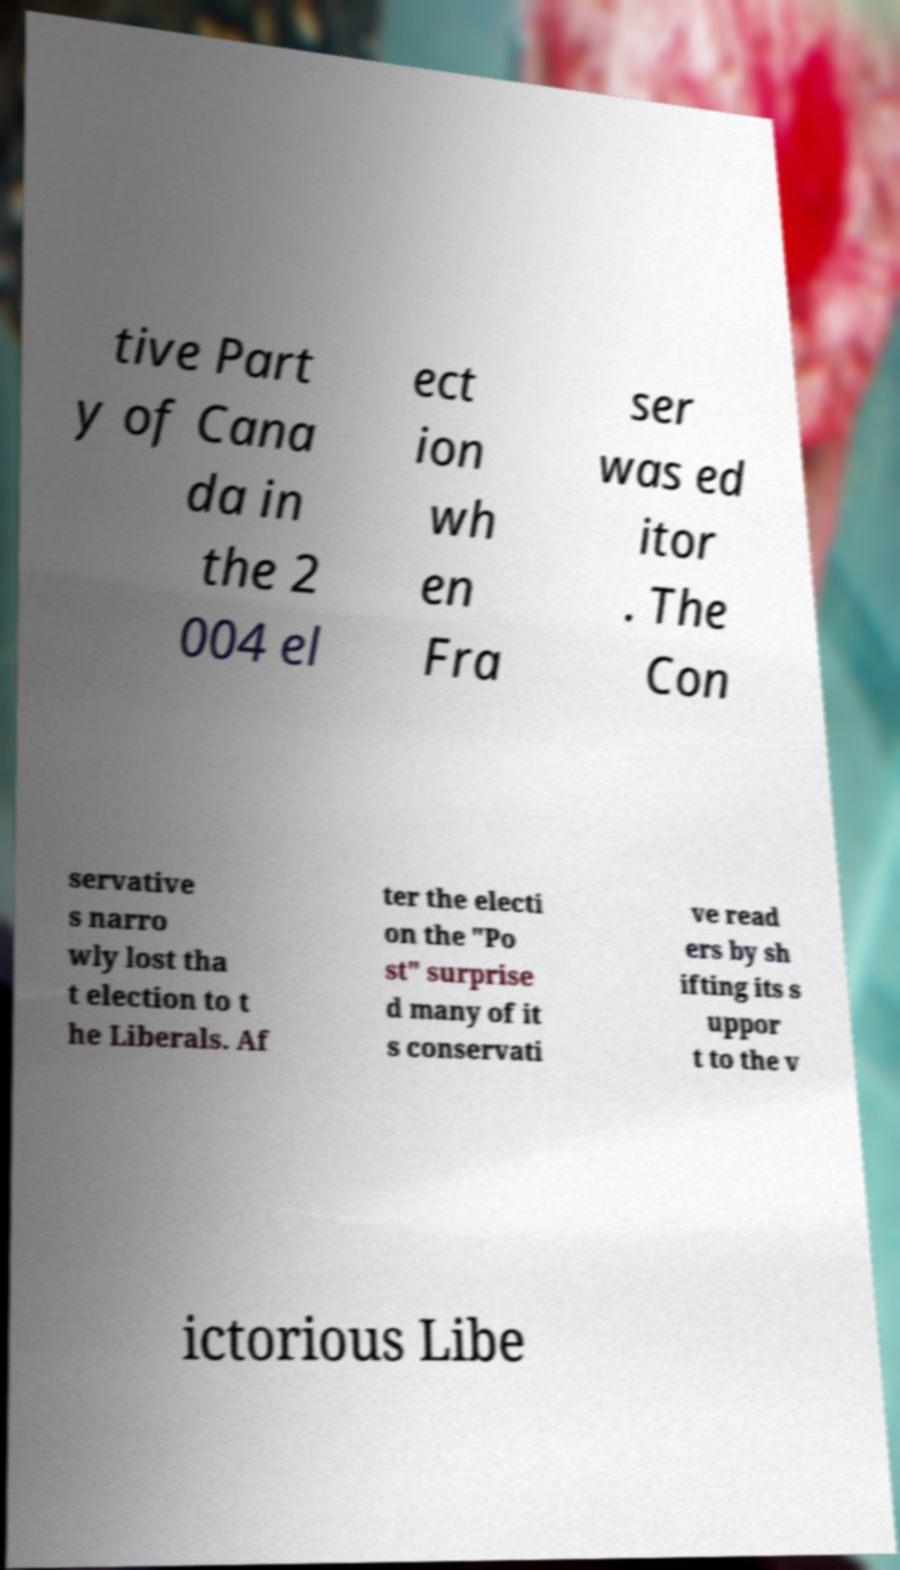Please read and relay the text visible in this image. What does it say? tive Part y of Cana da in the 2 004 el ect ion wh en Fra ser was ed itor . The Con servative s narro wly lost tha t election to t he Liberals. Af ter the electi on the "Po st" surprise d many of it s conservati ve read ers by sh ifting its s uppor t to the v ictorious Libe 